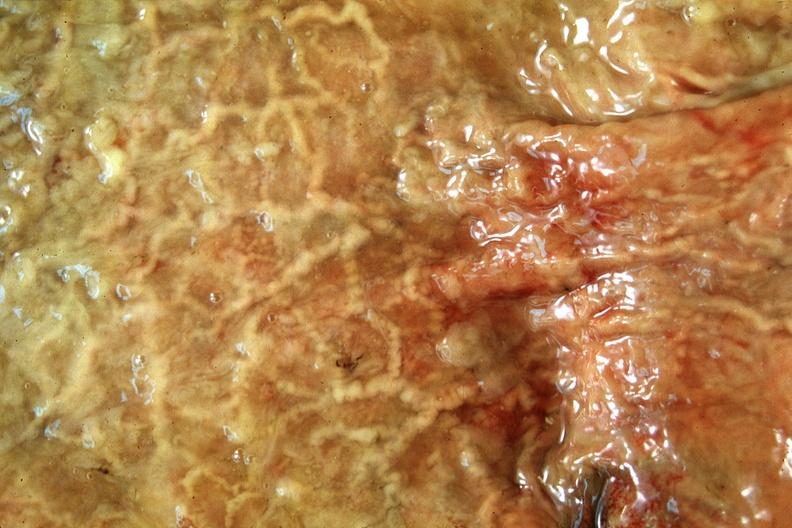s gastrointestinal present?
Answer the question using a single word or phrase. Yes 